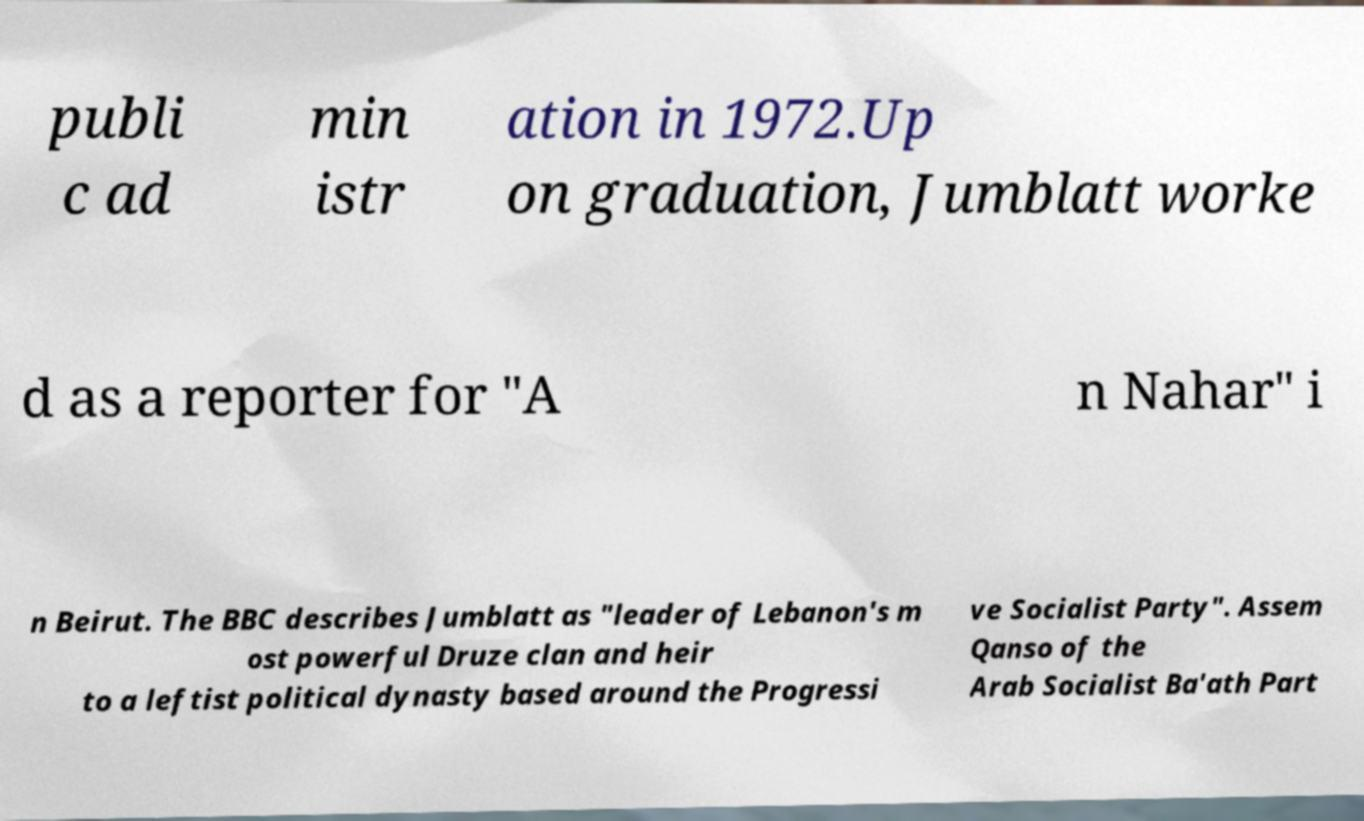There's text embedded in this image that I need extracted. Can you transcribe it verbatim? publi c ad min istr ation in 1972.Up on graduation, Jumblatt worke d as a reporter for "A n Nahar" i n Beirut. The BBC describes Jumblatt as "leader of Lebanon's m ost powerful Druze clan and heir to a leftist political dynasty based around the Progressi ve Socialist Party". Assem Qanso of the Arab Socialist Ba'ath Part 